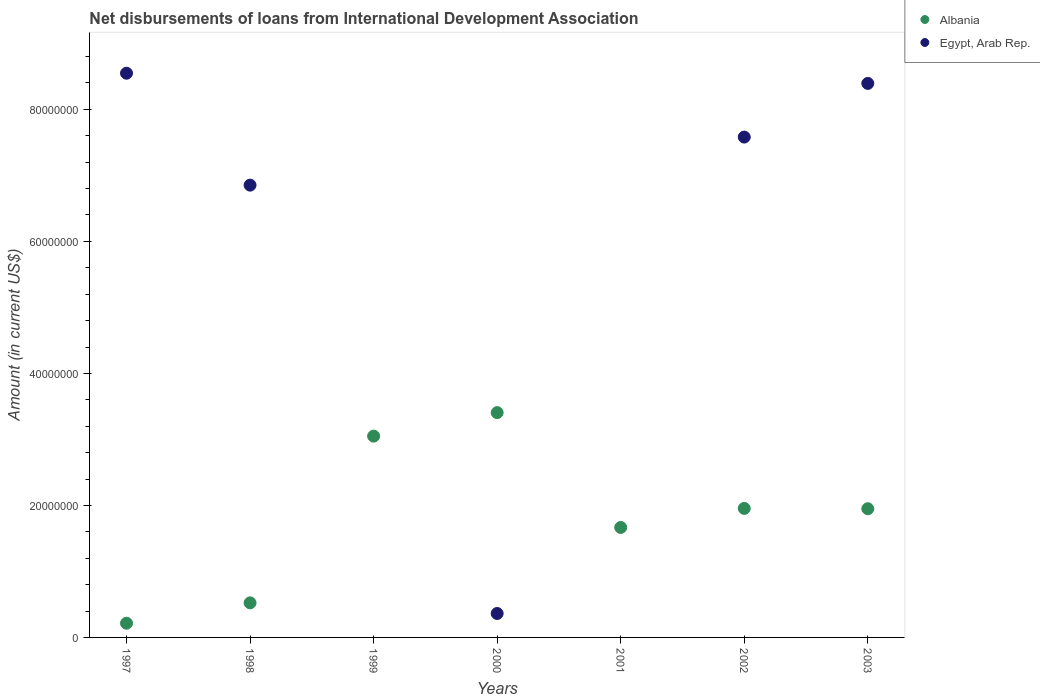Is the number of dotlines equal to the number of legend labels?
Keep it short and to the point. No. What is the amount of loans disbursed in Albania in 1997?
Provide a short and direct response. 2.15e+06. Across all years, what is the maximum amount of loans disbursed in Albania?
Your answer should be compact. 3.41e+07. Across all years, what is the minimum amount of loans disbursed in Albania?
Offer a very short reply. 2.15e+06. What is the total amount of loans disbursed in Albania in the graph?
Provide a short and direct response. 1.28e+08. What is the difference between the amount of loans disbursed in Egypt, Arab Rep. in 1998 and that in 2002?
Provide a short and direct response. -7.28e+06. What is the difference between the amount of loans disbursed in Albania in 2002 and the amount of loans disbursed in Egypt, Arab Rep. in 1999?
Provide a short and direct response. 1.95e+07. What is the average amount of loans disbursed in Egypt, Arab Rep. per year?
Provide a succinct answer. 4.53e+07. In the year 2003, what is the difference between the amount of loans disbursed in Albania and amount of loans disbursed in Egypt, Arab Rep.?
Keep it short and to the point. -6.44e+07. In how many years, is the amount of loans disbursed in Egypt, Arab Rep. greater than 40000000 US$?
Ensure brevity in your answer.  4. What is the ratio of the amount of loans disbursed in Albania in 1999 to that in 2002?
Your answer should be compact. 1.56. Is the amount of loans disbursed in Egypt, Arab Rep. in 1997 less than that in 2002?
Offer a very short reply. No. What is the difference between the highest and the second highest amount of loans disbursed in Egypt, Arab Rep.?
Your response must be concise. 1.55e+06. What is the difference between the highest and the lowest amount of loans disbursed in Albania?
Your response must be concise. 3.19e+07. In how many years, is the amount of loans disbursed in Albania greater than the average amount of loans disbursed in Albania taken over all years?
Offer a very short reply. 4. Is the sum of the amount of loans disbursed in Albania in 2000 and 2003 greater than the maximum amount of loans disbursed in Egypt, Arab Rep. across all years?
Provide a succinct answer. No. Is the amount of loans disbursed in Albania strictly greater than the amount of loans disbursed in Egypt, Arab Rep. over the years?
Provide a short and direct response. No. What is the difference between two consecutive major ticks on the Y-axis?
Provide a succinct answer. 2.00e+07. Does the graph contain any zero values?
Ensure brevity in your answer.  Yes. Does the graph contain grids?
Provide a short and direct response. No. Where does the legend appear in the graph?
Ensure brevity in your answer.  Top right. How are the legend labels stacked?
Make the answer very short. Vertical. What is the title of the graph?
Make the answer very short. Net disbursements of loans from International Development Association. Does "Jamaica" appear as one of the legend labels in the graph?
Give a very brief answer. No. What is the label or title of the Y-axis?
Keep it short and to the point. Amount (in current US$). What is the Amount (in current US$) in Albania in 1997?
Your answer should be very brief. 2.15e+06. What is the Amount (in current US$) of Egypt, Arab Rep. in 1997?
Provide a succinct answer. 8.55e+07. What is the Amount (in current US$) in Albania in 1998?
Make the answer very short. 5.24e+06. What is the Amount (in current US$) in Egypt, Arab Rep. in 1998?
Your answer should be compact. 6.85e+07. What is the Amount (in current US$) in Albania in 1999?
Give a very brief answer. 3.05e+07. What is the Amount (in current US$) in Albania in 2000?
Your answer should be compact. 3.41e+07. What is the Amount (in current US$) of Egypt, Arab Rep. in 2000?
Give a very brief answer. 3.63e+06. What is the Amount (in current US$) in Albania in 2001?
Offer a terse response. 1.67e+07. What is the Amount (in current US$) of Egypt, Arab Rep. in 2001?
Offer a terse response. 0. What is the Amount (in current US$) of Albania in 2002?
Provide a short and direct response. 1.95e+07. What is the Amount (in current US$) of Egypt, Arab Rep. in 2002?
Provide a short and direct response. 7.58e+07. What is the Amount (in current US$) in Albania in 2003?
Offer a very short reply. 1.95e+07. What is the Amount (in current US$) in Egypt, Arab Rep. in 2003?
Keep it short and to the point. 8.39e+07. Across all years, what is the maximum Amount (in current US$) of Albania?
Offer a very short reply. 3.41e+07. Across all years, what is the maximum Amount (in current US$) of Egypt, Arab Rep.?
Keep it short and to the point. 8.55e+07. Across all years, what is the minimum Amount (in current US$) in Albania?
Offer a terse response. 2.15e+06. What is the total Amount (in current US$) in Albania in the graph?
Provide a short and direct response. 1.28e+08. What is the total Amount (in current US$) of Egypt, Arab Rep. in the graph?
Provide a succinct answer. 3.17e+08. What is the difference between the Amount (in current US$) in Albania in 1997 and that in 1998?
Your answer should be very brief. -3.09e+06. What is the difference between the Amount (in current US$) in Egypt, Arab Rep. in 1997 and that in 1998?
Offer a very short reply. 1.70e+07. What is the difference between the Amount (in current US$) in Albania in 1997 and that in 1999?
Your answer should be very brief. -2.83e+07. What is the difference between the Amount (in current US$) of Albania in 1997 and that in 2000?
Offer a terse response. -3.19e+07. What is the difference between the Amount (in current US$) in Egypt, Arab Rep. in 1997 and that in 2000?
Provide a short and direct response. 8.19e+07. What is the difference between the Amount (in current US$) of Albania in 1997 and that in 2001?
Ensure brevity in your answer.  -1.45e+07. What is the difference between the Amount (in current US$) of Albania in 1997 and that in 2002?
Provide a short and direct response. -1.74e+07. What is the difference between the Amount (in current US$) in Egypt, Arab Rep. in 1997 and that in 2002?
Ensure brevity in your answer.  9.68e+06. What is the difference between the Amount (in current US$) in Albania in 1997 and that in 2003?
Provide a short and direct response. -1.73e+07. What is the difference between the Amount (in current US$) in Egypt, Arab Rep. in 1997 and that in 2003?
Give a very brief answer. 1.55e+06. What is the difference between the Amount (in current US$) in Albania in 1998 and that in 1999?
Your answer should be compact. -2.53e+07. What is the difference between the Amount (in current US$) of Albania in 1998 and that in 2000?
Your response must be concise. -2.88e+07. What is the difference between the Amount (in current US$) in Egypt, Arab Rep. in 1998 and that in 2000?
Ensure brevity in your answer.  6.49e+07. What is the difference between the Amount (in current US$) in Albania in 1998 and that in 2001?
Your response must be concise. -1.14e+07. What is the difference between the Amount (in current US$) in Albania in 1998 and that in 2002?
Offer a very short reply. -1.43e+07. What is the difference between the Amount (in current US$) of Egypt, Arab Rep. in 1998 and that in 2002?
Keep it short and to the point. -7.28e+06. What is the difference between the Amount (in current US$) in Albania in 1998 and that in 2003?
Provide a succinct answer. -1.43e+07. What is the difference between the Amount (in current US$) in Egypt, Arab Rep. in 1998 and that in 2003?
Your response must be concise. -1.54e+07. What is the difference between the Amount (in current US$) in Albania in 1999 and that in 2000?
Your answer should be very brief. -3.56e+06. What is the difference between the Amount (in current US$) in Albania in 1999 and that in 2001?
Provide a short and direct response. 1.38e+07. What is the difference between the Amount (in current US$) of Albania in 1999 and that in 2002?
Make the answer very short. 1.10e+07. What is the difference between the Amount (in current US$) in Albania in 1999 and that in 2003?
Your response must be concise. 1.10e+07. What is the difference between the Amount (in current US$) in Albania in 2000 and that in 2001?
Offer a terse response. 1.74e+07. What is the difference between the Amount (in current US$) in Albania in 2000 and that in 2002?
Give a very brief answer. 1.45e+07. What is the difference between the Amount (in current US$) of Egypt, Arab Rep. in 2000 and that in 2002?
Offer a very short reply. -7.22e+07. What is the difference between the Amount (in current US$) of Albania in 2000 and that in 2003?
Offer a terse response. 1.46e+07. What is the difference between the Amount (in current US$) of Egypt, Arab Rep. in 2000 and that in 2003?
Provide a short and direct response. -8.03e+07. What is the difference between the Amount (in current US$) of Albania in 2001 and that in 2002?
Your answer should be compact. -2.88e+06. What is the difference between the Amount (in current US$) in Albania in 2001 and that in 2003?
Keep it short and to the point. -2.84e+06. What is the difference between the Amount (in current US$) of Albania in 2002 and that in 2003?
Give a very brief answer. 4.80e+04. What is the difference between the Amount (in current US$) of Egypt, Arab Rep. in 2002 and that in 2003?
Keep it short and to the point. -8.13e+06. What is the difference between the Amount (in current US$) in Albania in 1997 and the Amount (in current US$) in Egypt, Arab Rep. in 1998?
Ensure brevity in your answer.  -6.64e+07. What is the difference between the Amount (in current US$) of Albania in 1997 and the Amount (in current US$) of Egypt, Arab Rep. in 2000?
Your response must be concise. -1.48e+06. What is the difference between the Amount (in current US$) of Albania in 1997 and the Amount (in current US$) of Egypt, Arab Rep. in 2002?
Give a very brief answer. -7.37e+07. What is the difference between the Amount (in current US$) in Albania in 1997 and the Amount (in current US$) in Egypt, Arab Rep. in 2003?
Provide a succinct answer. -8.18e+07. What is the difference between the Amount (in current US$) in Albania in 1998 and the Amount (in current US$) in Egypt, Arab Rep. in 2000?
Your answer should be very brief. 1.61e+06. What is the difference between the Amount (in current US$) of Albania in 1998 and the Amount (in current US$) of Egypt, Arab Rep. in 2002?
Make the answer very short. -7.06e+07. What is the difference between the Amount (in current US$) of Albania in 1998 and the Amount (in current US$) of Egypt, Arab Rep. in 2003?
Give a very brief answer. -7.87e+07. What is the difference between the Amount (in current US$) in Albania in 1999 and the Amount (in current US$) in Egypt, Arab Rep. in 2000?
Your answer should be compact. 2.69e+07. What is the difference between the Amount (in current US$) in Albania in 1999 and the Amount (in current US$) in Egypt, Arab Rep. in 2002?
Keep it short and to the point. -4.53e+07. What is the difference between the Amount (in current US$) in Albania in 1999 and the Amount (in current US$) in Egypt, Arab Rep. in 2003?
Your answer should be compact. -5.34e+07. What is the difference between the Amount (in current US$) in Albania in 2000 and the Amount (in current US$) in Egypt, Arab Rep. in 2002?
Offer a very short reply. -4.17e+07. What is the difference between the Amount (in current US$) in Albania in 2000 and the Amount (in current US$) in Egypt, Arab Rep. in 2003?
Ensure brevity in your answer.  -4.99e+07. What is the difference between the Amount (in current US$) of Albania in 2001 and the Amount (in current US$) of Egypt, Arab Rep. in 2002?
Keep it short and to the point. -5.91e+07. What is the difference between the Amount (in current US$) of Albania in 2001 and the Amount (in current US$) of Egypt, Arab Rep. in 2003?
Offer a terse response. -6.73e+07. What is the difference between the Amount (in current US$) of Albania in 2002 and the Amount (in current US$) of Egypt, Arab Rep. in 2003?
Provide a short and direct response. -6.44e+07. What is the average Amount (in current US$) in Albania per year?
Ensure brevity in your answer.  1.82e+07. What is the average Amount (in current US$) of Egypt, Arab Rep. per year?
Offer a terse response. 4.53e+07. In the year 1997, what is the difference between the Amount (in current US$) of Albania and Amount (in current US$) of Egypt, Arab Rep.?
Offer a terse response. -8.33e+07. In the year 1998, what is the difference between the Amount (in current US$) in Albania and Amount (in current US$) in Egypt, Arab Rep.?
Offer a very short reply. -6.33e+07. In the year 2000, what is the difference between the Amount (in current US$) of Albania and Amount (in current US$) of Egypt, Arab Rep.?
Make the answer very short. 3.04e+07. In the year 2002, what is the difference between the Amount (in current US$) in Albania and Amount (in current US$) in Egypt, Arab Rep.?
Provide a succinct answer. -5.63e+07. In the year 2003, what is the difference between the Amount (in current US$) in Albania and Amount (in current US$) in Egypt, Arab Rep.?
Offer a very short reply. -6.44e+07. What is the ratio of the Amount (in current US$) in Albania in 1997 to that in 1998?
Your answer should be compact. 0.41. What is the ratio of the Amount (in current US$) of Egypt, Arab Rep. in 1997 to that in 1998?
Make the answer very short. 1.25. What is the ratio of the Amount (in current US$) in Albania in 1997 to that in 1999?
Give a very brief answer. 0.07. What is the ratio of the Amount (in current US$) in Albania in 1997 to that in 2000?
Offer a terse response. 0.06. What is the ratio of the Amount (in current US$) of Egypt, Arab Rep. in 1997 to that in 2000?
Give a very brief answer. 23.57. What is the ratio of the Amount (in current US$) in Albania in 1997 to that in 2001?
Make the answer very short. 0.13. What is the ratio of the Amount (in current US$) of Albania in 1997 to that in 2002?
Give a very brief answer. 0.11. What is the ratio of the Amount (in current US$) of Egypt, Arab Rep. in 1997 to that in 2002?
Offer a very short reply. 1.13. What is the ratio of the Amount (in current US$) in Albania in 1997 to that in 2003?
Keep it short and to the point. 0.11. What is the ratio of the Amount (in current US$) of Egypt, Arab Rep. in 1997 to that in 2003?
Provide a succinct answer. 1.02. What is the ratio of the Amount (in current US$) in Albania in 1998 to that in 1999?
Your answer should be very brief. 0.17. What is the ratio of the Amount (in current US$) in Albania in 1998 to that in 2000?
Give a very brief answer. 0.15. What is the ratio of the Amount (in current US$) of Egypt, Arab Rep. in 1998 to that in 2000?
Provide a short and direct response. 18.89. What is the ratio of the Amount (in current US$) of Albania in 1998 to that in 2001?
Offer a very short reply. 0.31. What is the ratio of the Amount (in current US$) in Albania in 1998 to that in 2002?
Offer a very short reply. 0.27. What is the ratio of the Amount (in current US$) in Egypt, Arab Rep. in 1998 to that in 2002?
Offer a very short reply. 0.9. What is the ratio of the Amount (in current US$) of Albania in 1998 to that in 2003?
Provide a succinct answer. 0.27. What is the ratio of the Amount (in current US$) of Egypt, Arab Rep. in 1998 to that in 2003?
Offer a very short reply. 0.82. What is the ratio of the Amount (in current US$) of Albania in 1999 to that in 2000?
Offer a terse response. 0.9. What is the ratio of the Amount (in current US$) in Albania in 1999 to that in 2001?
Offer a terse response. 1.83. What is the ratio of the Amount (in current US$) in Albania in 1999 to that in 2002?
Provide a succinct answer. 1.56. What is the ratio of the Amount (in current US$) of Albania in 1999 to that in 2003?
Offer a very short reply. 1.56. What is the ratio of the Amount (in current US$) in Albania in 2000 to that in 2001?
Your answer should be very brief. 2.04. What is the ratio of the Amount (in current US$) in Albania in 2000 to that in 2002?
Give a very brief answer. 1.74. What is the ratio of the Amount (in current US$) of Egypt, Arab Rep. in 2000 to that in 2002?
Make the answer very short. 0.05. What is the ratio of the Amount (in current US$) of Albania in 2000 to that in 2003?
Your answer should be compact. 1.75. What is the ratio of the Amount (in current US$) of Egypt, Arab Rep. in 2000 to that in 2003?
Your answer should be very brief. 0.04. What is the ratio of the Amount (in current US$) in Albania in 2001 to that in 2002?
Offer a very short reply. 0.85. What is the ratio of the Amount (in current US$) of Albania in 2001 to that in 2003?
Keep it short and to the point. 0.85. What is the ratio of the Amount (in current US$) of Egypt, Arab Rep. in 2002 to that in 2003?
Provide a succinct answer. 0.9. What is the difference between the highest and the second highest Amount (in current US$) of Albania?
Make the answer very short. 3.56e+06. What is the difference between the highest and the second highest Amount (in current US$) in Egypt, Arab Rep.?
Your answer should be compact. 1.55e+06. What is the difference between the highest and the lowest Amount (in current US$) in Albania?
Offer a terse response. 3.19e+07. What is the difference between the highest and the lowest Amount (in current US$) of Egypt, Arab Rep.?
Your answer should be very brief. 8.55e+07. 